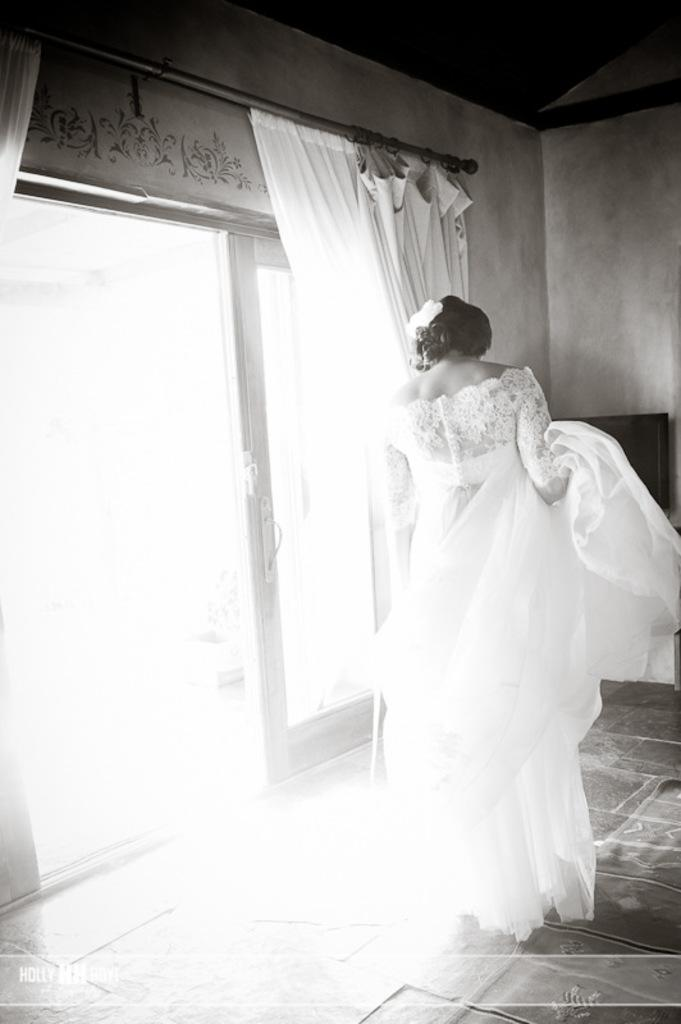Who is present in the image? There is a woman in the image. What is the woman wearing? The woman is wearing a white dress. What is the woman's posture in the image? The woman is standing. What type of door can be seen in the image? There is a glass door in the image. What type of window treatment is present in the image? There is a curtain in the image. What type of soda is being served in the image? There is no soda present in the image. What is the woman using to weigh herself in the image? There is no scale present in the image, and the woman is not weighing herself. 